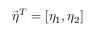Convert formula to latex. <formula><loc_0><loc_0><loc_500><loc_500>\vec { \eta } ^ { T } = \left [ \eta _ { 1 } , \eta _ { 2 } \right ]</formula> 